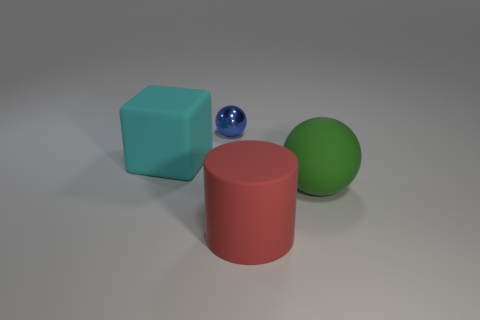Are there more green objects right of the red cylinder than small gray metallic cubes?
Provide a succinct answer. Yes. Is there anything else that has the same size as the green matte object?
Provide a short and direct response. Yes. Does the cylinder have the same color as the rubber object behind the big green matte object?
Your answer should be compact. No. Are there an equal number of tiny blue objects on the right side of the metal sphere and blue things in front of the matte cylinder?
Keep it short and to the point. Yes. What is the sphere in front of the small object made of?
Give a very brief answer. Rubber. How many things are either things that are behind the red thing or tiny metal spheres?
Offer a terse response. 3. What number of other objects are the same shape as the large cyan matte thing?
Provide a succinct answer. 0. There is a big object that is in front of the big green sphere; does it have the same shape as the cyan thing?
Your answer should be compact. No. Are there any large cyan matte objects on the right side of the big red matte thing?
Keep it short and to the point. No. How many big things are brown objects or cyan things?
Keep it short and to the point. 1. 